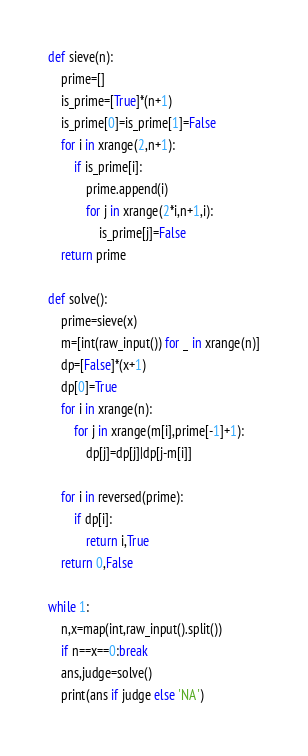Convert code to text. <code><loc_0><loc_0><loc_500><loc_500><_Python_>def sieve(n):
    prime=[]
    is_prime=[True]*(n+1)
    is_prime[0]=is_prime[1]=False
    for i in xrange(2,n+1):
        if is_prime[i]:
            prime.append(i)
            for j in xrange(2*i,n+1,i):
                is_prime[j]=False
    return prime

def solve():
    prime=sieve(x)
    m=[int(raw_input()) for _ in xrange(n)]
    dp=[False]*(x+1)
    dp[0]=True
    for i in xrange(n):
        for j in xrange(m[i],prime[-1]+1):
            dp[j]=dp[j]|dp[j-m[i]]

    for i in reversed(prime):
        if dp[i]:
            return i,True
    return 0,False

while 1:
    n,x=map(int,raw_input().split())
    if n==x==0:break
    ans,judge=solve()
    print(ans if judge else 'NA')</code> 